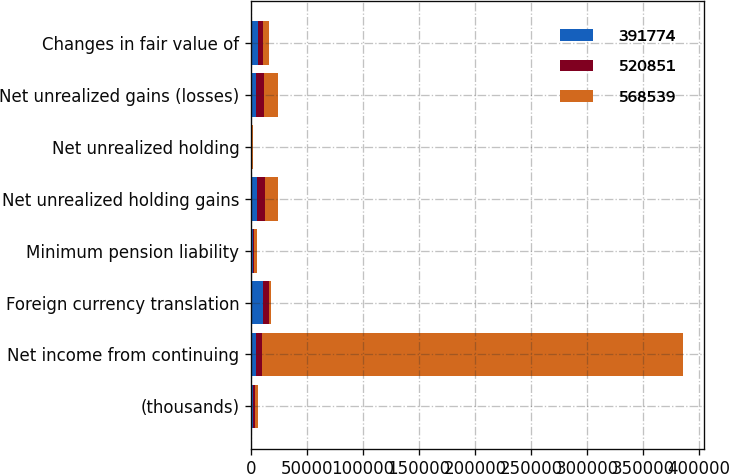Convert chart. <chart><loc_0><loc_0><loc_500><loc_500><stacked_bar_chart><ecel><fcel>(thousands)<fcel>Net income from continuing<fcel>Foreign currency translation<fcel>Minimum pension liability<fcel>Net unrealized holding gains<fcel>Net unrealized holding<fcel>Net unrealized gains (losses)<fcel>Changes in fair value of<nl><fcel>391774<fcel>2007<fcel>4797<fcel>10640<fcel>1495<fcel>5094<fcel>185<fcel>4909<fcel>6128<nl><fcel>520851<fcel>2006<fcel>4797<fcel>5838<fcel>1398<fcel>7492<fcel>436<fcel>7056<fcel>4876<nl><fcel>568539<fcel>2005<fcel>375944<fcel>1595<fcel>2461<fcel>11586<fcel>930<fcel>12516<fcel>4718<nl></chart> 